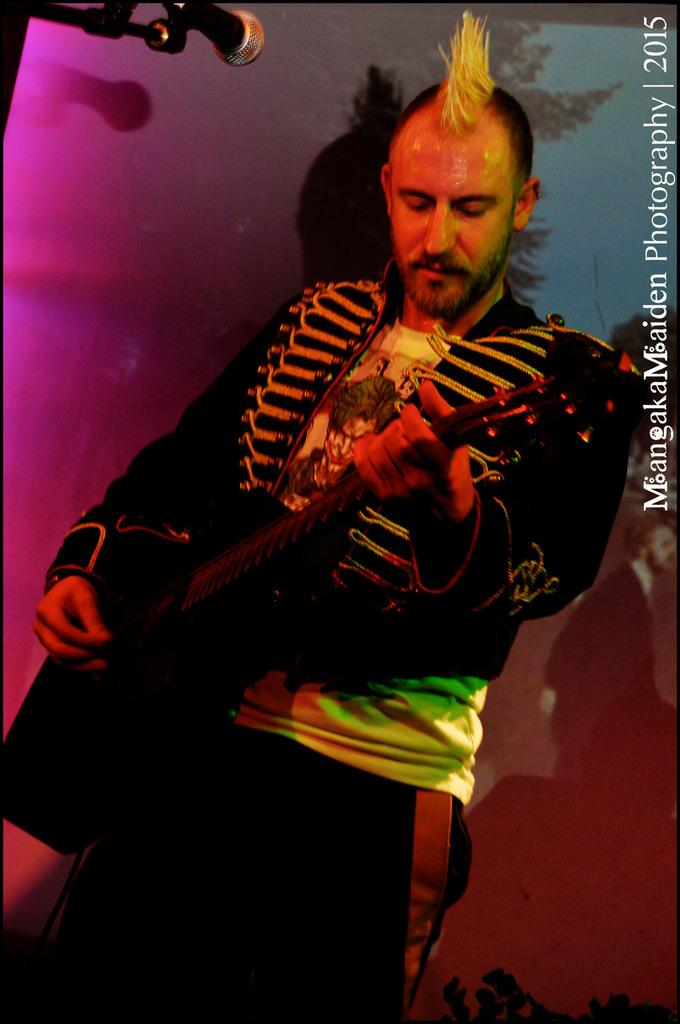What is the man in the image holding? The man is holding a guitar. What is the man doing with the guitar? The man is playing the guitar. What is in front of the man? There is a microphone in front of the man. What can be seen in the background of the image? There are colorful lights and a person on a banner in the background. Reasoning: Let' Let's think step by step in order to produce the conversation. We start by identifying the main subject in the image, which is the man. Then, we describe what he is holding and doing, which is playing a guitar. Next, we mention the microphone in front of him, which suggests a performance or recording context. Finally, we describe the background elements, including the colorful lights and the person on the banner. Absurd Question/Answer: What type of pump can be seen in the image? There is no pump present in the image. What season is depicted in the image, considering the presence of winter elements? There are no winter elements present in the image, so it cannot be determined that the image depicts a specific season. 